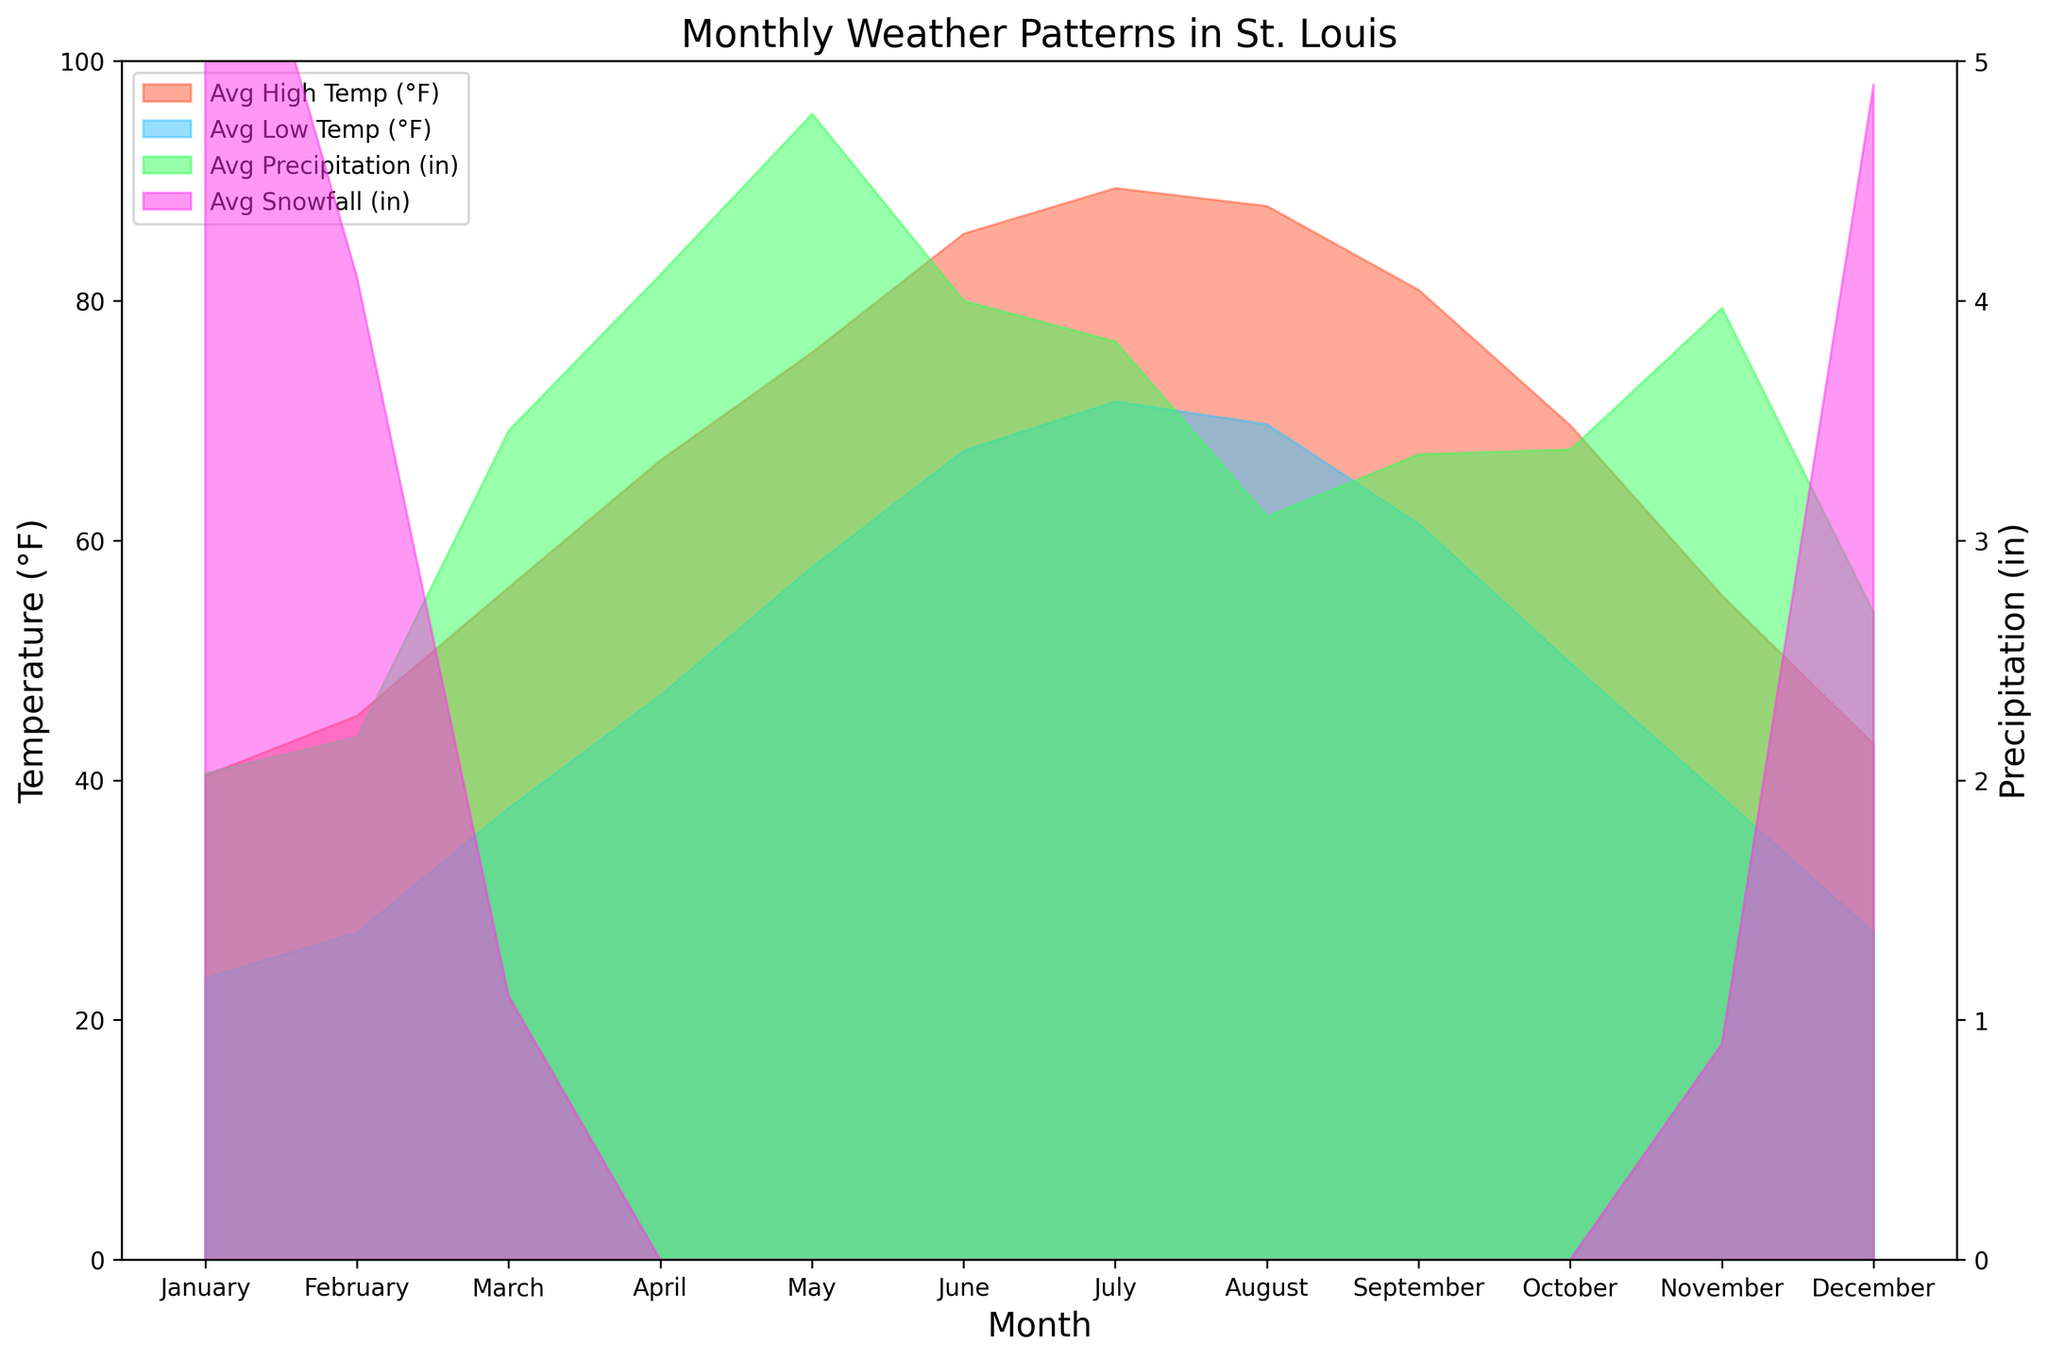What is the average high temperature in St. Louis in July? To find the average high temperature for July, look at the area shaded in the red color representing "Avg High Temp (°F)" for the month of July. It indicates a value of 89.4°F.
Answer: 89.4°F How does the average low temperature in January compare to July? Compare the area shaded in the blue color for January and July representing "Avg Low Temp (°F)". The January average low is 23.5°F and the July average low is 71.6°F. July is significantly warmer.
Answer: July is significantly warmer by 48.1°F Which month has the highest average precipitation? Look at the green shaded area representing "Avg Precipitation (in)" for all the months. The highest peak occurs in May, which is 4.78 inches.
Answer: May In which month does St. Louis typically experience the most snowfall? Identify the pink shaded area representing "Avg Snowfall (in)". The highest value is during January, with 6.3 inches of snowfall.
Answer: January How much more snowfall occurs in January compared to December on average? Look at the pink shaded areas for January and December representing "Avg Snowfall (in)". January has 6.3 inches, while December has 4.9 inches. The difference is 6.3 - 4.9 = 1.4 inches.
Answer: 1.4 inches What is the difference between the average high temperature and average low temperature in March? Identify the red and blue shaded areas for March. The average high is 56.1°F and the average low is 37.7°F. The difference is 56.1 - 37.7 = 18.4°F.
Answer: 18.4°F Which has more variability over the months, temperature or precipitation? Compare the range of values for the red/blue areas (temperatures) and green/pink areas (precipitation). The temperature ranges from 23.5°F to 89.4°F (65.9°F difference), and precipitation ranges from 2.03 to 4.78 inches (2.75 inches difference). Temperature shows more variability.
Answer: Temperature How many months have an average low temperature below freezing (32°F)? Look at the blue shaded area and count the months where the average low temperature line is below 32°F. Those months are January, February, and December, totaling 3 months.
Answer: 3 months What is the total average precipitation for the summer months (June, July, August)? Add the values from the green shaded area for June, July, and August. June has 4.0 inches, July has 3.83 inches, and August has 3.1 inches. The total is 4.0 + 3.83 + 3.1 = 10.93 inches.
Answer: 10.93 inches What is the trend of average high temperatures from January to August? Observe the red shaded area from January to August. The temperature shows an increasing trend, starting at 40.4°F in January and reaching a peak of 89.4°F in July before slightly dropping to 87.9°F in August.
Answer: Increasing trend 